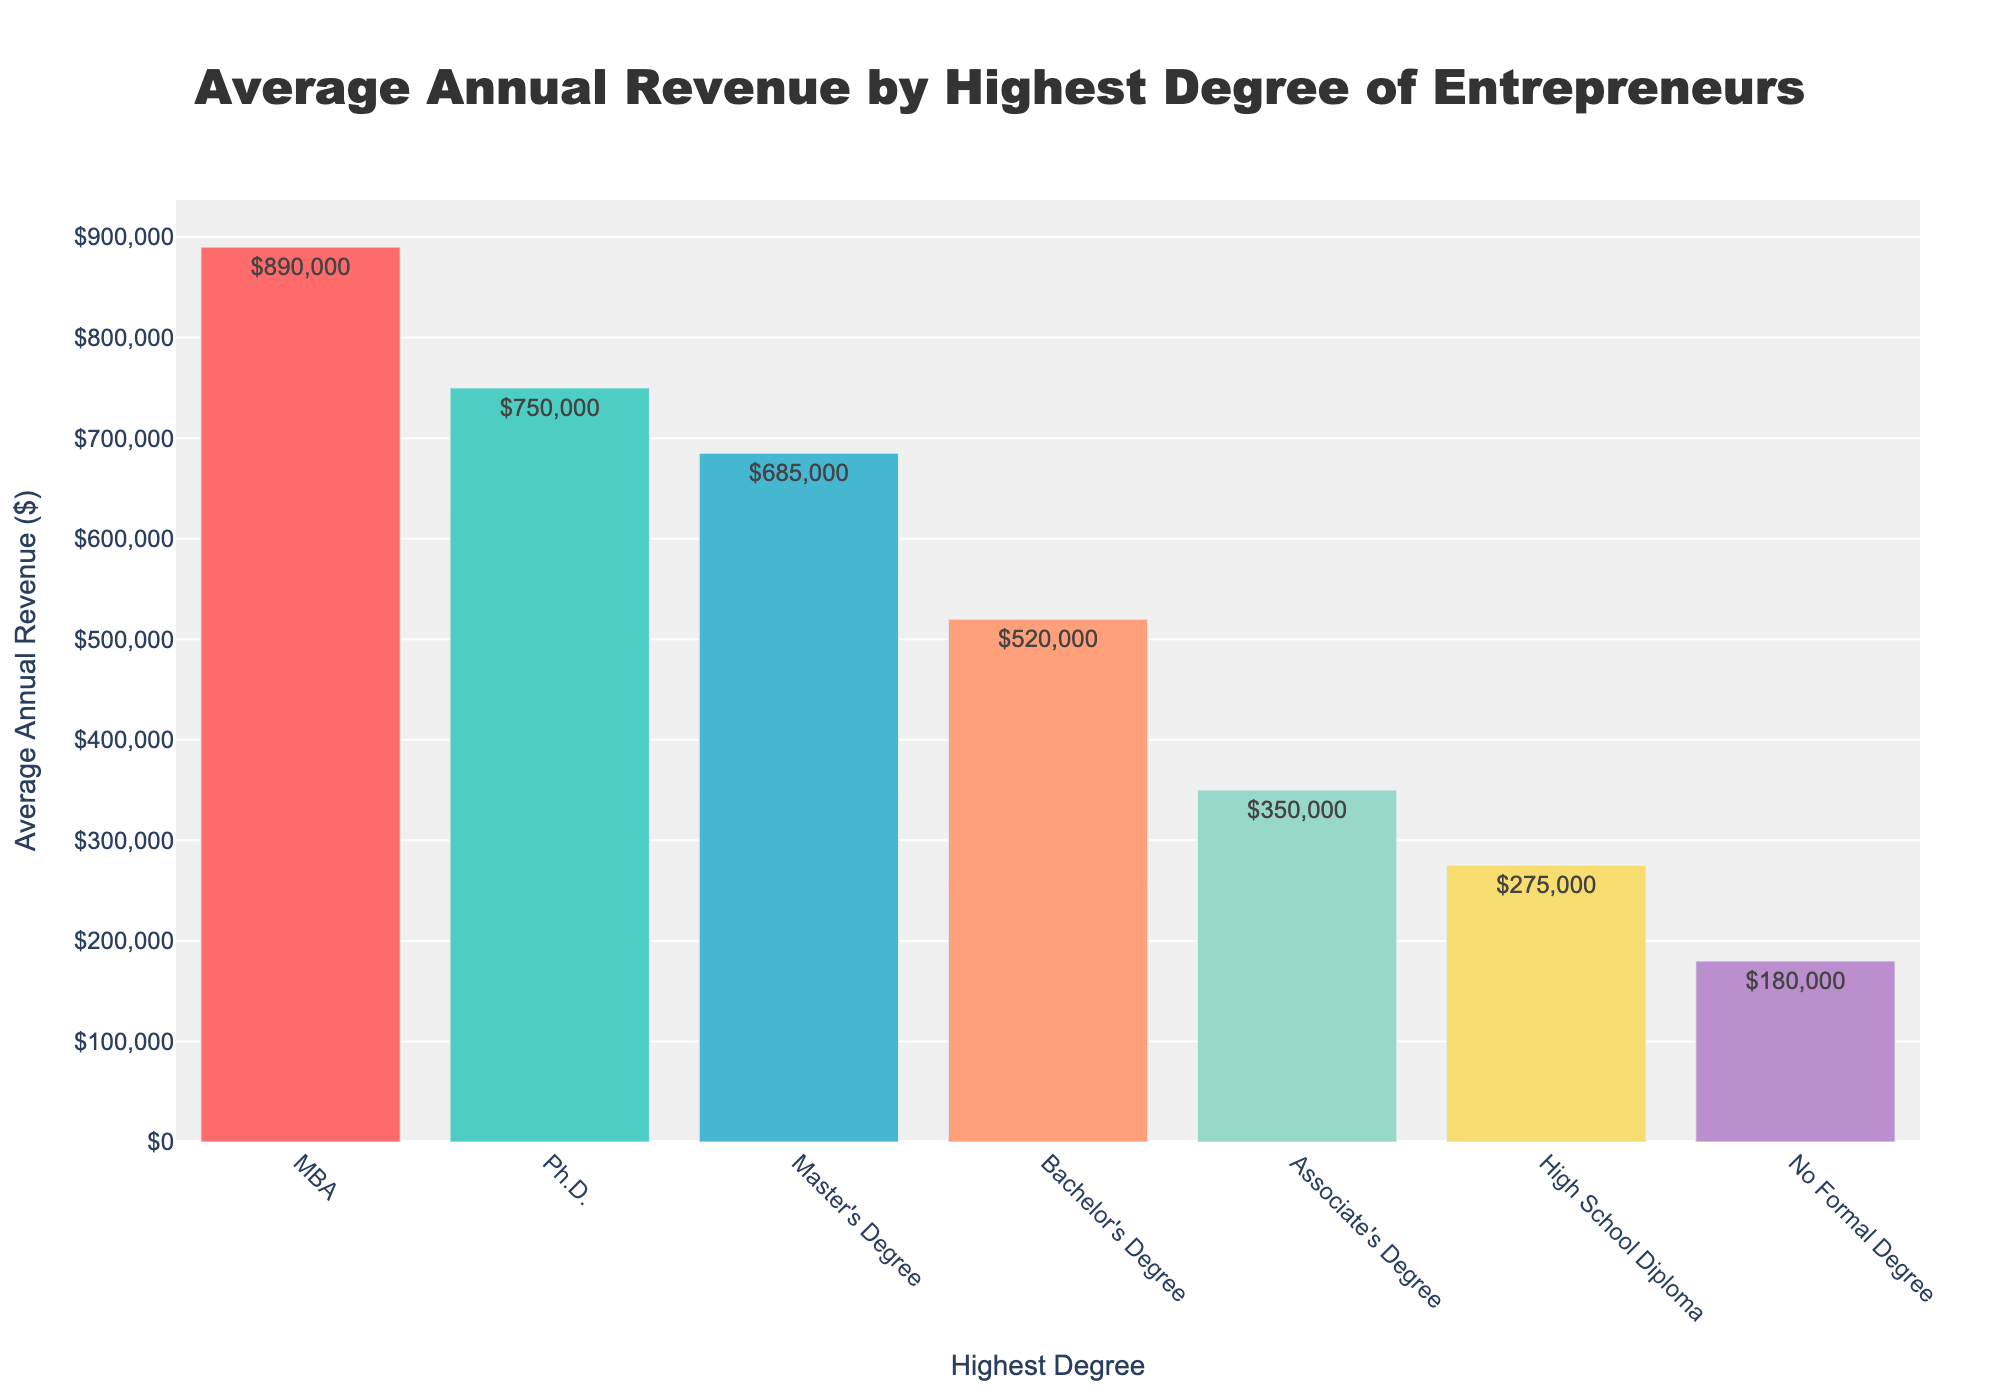What is the average annual revenue for entrepreneurs with an MBA? The bar representing MBA shows an average annual revenue of $890,000.
Answer: $890,000 Which educational category has the lowest average annual revenue? The bar representing "No Formal Degree" is the shortest, indicating it has the lowest average annual revenue of $180,000.
Answer: No Formal Degree What is the difference in average annual revenue between entrepreneurs with a Ph.D. and those with a Bachelor's Degree? The revenue for a Ph.D. is $750,000 and for a Bachelor's Degree is $520,000. The difference is $750,000 - $520,000 = $230,000.
Answer: $230,000 How does the average revenue of entrepreneurs with an Associate's Degree compare to those with a Master's Degree? The average revenue for an Associate's Degree is $350,000, and for a Master's Degree, it is $685,000. Comparing these, $685,000 is significantly higher than $350,000.
Answer: Master's Degree is higher What is the total average annual revenue for entrepreneurs with a High School Diploma, Associate's Degree, and Bachelor's Degree combined? Adding the average annual revenues: $275,000 + $350,000 + $520,000 = $1,145,000.
Answer: $1,145,000 Rank the educational categories by their average annual revenue from highest to lowest. Ordering the revenues from highest to lowest: MBA ($890,000), Ph.D. ($750,000), Master's Degree ($685,000), Bachelor's Degree ($520,000), Associate's Degree ($350,000), High School Diploma ($275,000), No Formal Degree ($180,000).
Answer: MBA, Ph.D., Master's Degree, Bachelor's Degree, Associate's Degree, High School Diploma, No Formal Degree What is the median average annual revenue among all the educational categories? Listing the revenues in ascending order: $180,000, $275,000, $350,000, $520,000, $685,000, $750,000, $890,000. The median value (middle value in an odd set) is $520,000.
Answer: $520,000 Is the average annual revenue for entrepreneurs with an MBA more than double that of those with only a High School Diploma? The revenue for an MBA is $890,000, and for a High School Diploma, it is $275,000. Checking if $890,000 is more than double $275,000 ($275,000 * 2 = $550,000), yes, $890,000 is greater.
Answer: Yes Which degree shows a higher average annual revenue: Master's Degree or Ph.D.? Comparing the two values, Master's Degree ($685,000) and Ph.D. ($750,000), shows that a Ph.D. has a higher revenue.
Answer: Ph.D 